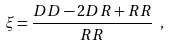<formula> <loc_0><loc_0><loc_500><loc_500>\xi = \frac { D D - 2 D R + R R } { R R } \ ,</formula> 